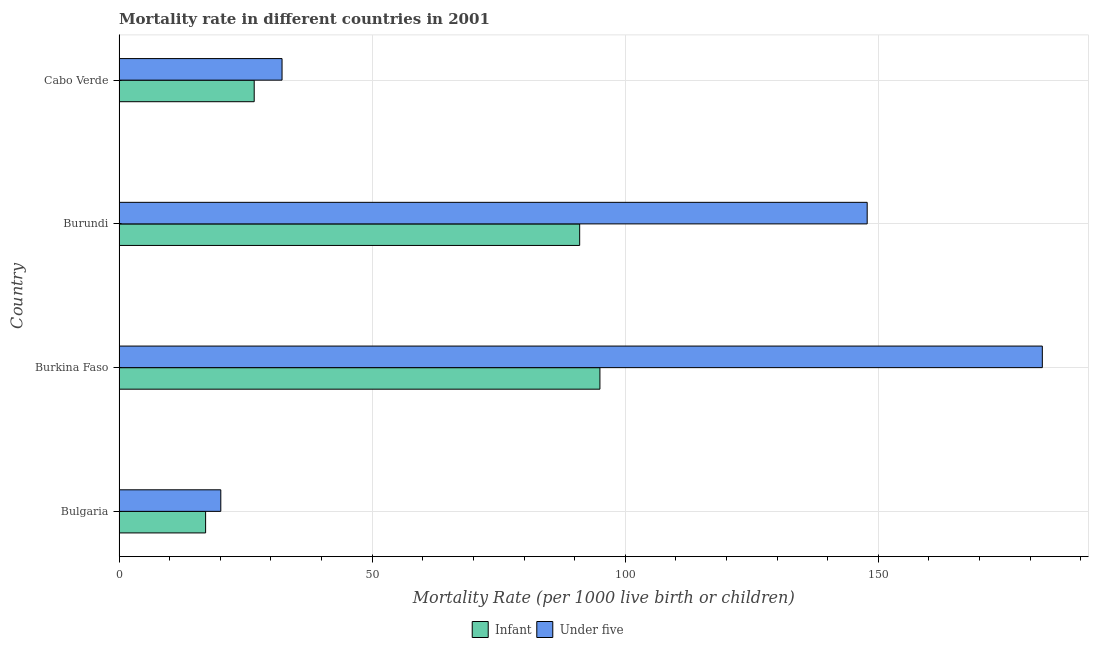How many different coloured bars are there?
Offer a terse response. 2. How many groups of bars are there?
Offer a terse response. 4. Are the number of bars on each tick of the Y-axis equal?
Give a very brief answer. Yes. How many bars are there on the 1st tick from the top?
Ensure brevity in your answer.  2. What is the label of the 4th group of bars from the top?
Keep it short and to the point. Bulgaria. What is the under-5 mortality rate in Bulgaria?
Make the answer very short. 20.1. In which country was the infant mortality rate maximum?
Ensure brevity in your answer.  Burkina Faso. In which country was the under-5 mortality rate minimum?
Your answer should be compact. Bulgaria. What is the total under-5 mortality rate in the graph?
Your answer should be very brief. 382.5. What is the difference between the infant mortality rate in Bulgaria and that in Burundi?
Make the answer very short. -73.9. What is the difference between the infant mortality rate in Burundi and the under-5 mortality rate in Burkina Faso?
Offer a very short reply. -91.4. What is the average under-5 mortality rate per country?
Give a very brief answer. 95.62. What is the ratio of the infant mortality rate in Bulgaria to that in Burundi?
Provide a short and direct response. 0.19. Is the difference between the under-5 mortality rate in Bulgaria and Cabo Verde greater than the difference between the infant mortality rate in Bulgaria and Cabo Verde?
Make the answer very short. No. What is the difference between the highest and the lowest under-5 mortality rate?
Offer a very short reply. 162.3. What does the 1st bar from the top in Burkina Faso represents?
Provide a succinct answer. Under five. What does the 2nd bar from the bottom in Burkina Faso represents?
Your response must be concise. Under five. How many bars are there?
Offer a very short reply. 8. Are all the bars in the graph horizontal?
Your answer should be compact. Yes. How many countries are there in the graph?
Provide a succinct answer. 4. Are the values on the major ticks of X-axis written in scientific E-notation?
Make the answer very short. No. Does the graph contain any zero values?
Give a very brief answer. No. Where does the legend appear in the graph?
Your answer should be very brief. Bottom center. How many legend labels are there?
Give a very brief answer. 2. What is the title of the graph?
Offer a terse response. Mortality rate in different countries in 2001. What is the label or title of the X-axis?
Your response must be concise. Mortality Rate (per 1000 live birth or children). What is the Mortality Rate (per 1000 live birth or children) in Infant in Bulgaria?
Provide a short and direct response. 17.1. What is the Mortality Rate (per 1000 live birth or children) of Under five in Bulgaria?
Offer a terse response. 20.1. What is the Mortality Rate (per 1000 live birth or children) in Infant in Burkina Faso?
Ensure brevity in your answer.  95. What is the Mortality Rate (per 1000 live birth or children) of Under five in Burkina Faso?
Make the answer very short. 182.4. What is the Mortality Rate (per 1000 live birth or children) in Infant in Burundi?
Offer a terse response. 91. What is the Mortality Rate (per 1000 live birth or children) in Under five in Burundi?
Your answer should be compact. 147.8. What is the Mortality Rate (per 1000 live birth or children) in Infant in Cabo Verde?
Keep it short and to the point. 26.7. What is the Mortality Rate (per 1000 live birth or children) in Under five in Cabo Verde?
Provide a short and direct response. 32.2. Across all countries, what is the maximum Mortality Rate (per 1000 live birth or children) in Under five?
Ensure brevity in your answer.  182.4. Across all countries, what is the minimum Mortality Rate (per 1000 live birth or children) of Under five?
Provide a succinct answer. 20.1. What is the total Mortality Rate (per 1000 live birth or children) in Infant in the graph?
Your response must be concise. 229.8. What is the total Mortality Rate (per 1000 live birth or children) in Under five in the graph?
Offer a terse response. 382.5. What is the difference between the Mortality Rate (per 1000 live birth or children) of Infant in Bulgaria and that in Burkina Faso?
Your answer should be very brief. -77.9. What is the difference between the Mortality Rate (per 1000 live birth or children) in Under five in Bulgaria and that in Burkina Faso?
Your answer should be very brief. -162.3. What is the difference between the Mortality Rate (per 1000 live birth or children) of Infant in Bulgaria and that in Burundi?
Your response must be concise. -73.9. What is the difference between the Mortality Rate (per 1000 live birth or children) of Under five in Bulgaria and that in Burundi?
Give a very brief answer. -127.7. What is the difference between the Mortality Rate (per 1000 live birth or children) in Under five in Bulgaria and that in Cabo Verde?
Your answer should be compact. -12.1. What is the difference between the Mortality Rate (per 1000 live birth or children) in Under five in Burkina Faso and that in Burundi?
Provide a succinct answer. 34.6. What is the difference between the Mortality Rate (per 1000 live birth or children) in Infant in Burkina Faso and that in Cabo Verde?
Provide a succinct answer. 68.3. What is the difference between the Mortality Rate (per 1000 live birth or children) of Under five in Burkina Faso and that in Cabo Verde?
Offer a very short reply. 150.2. What is the difference between the Mortality Rate (per 1000 live birth or children) in Infant in Burundi and that in Cabo Verde?
Keep it short and to the point. 64.3. What is the difference between the Mortality Rate (per 1000 live birth or children) of Under five in Burundi and that in Cabo Verde?
Keep it short and to the point. 115.6. What is the difference between the Mortality Rate (per 1000 live birth or children) of Infant in Bulgaria and the Mortality Rate (per 1000 live birth or children) of Under five in Burkina Faso?
Keep it short and to the point. -165.3. What is the difference between the Mortality Rate (per 1000 live birth or children) of Infant in Bulgaria and the Mortality Rate (per 1000 live birth or children) of Under five in Burundi?
Ensure brevity in your answer.  -130.7. What is the difference between the Mortality Rate (per 1000 live birth or children) in Infant in Bulgaria and the Mortality Rate (per 1000 live birth or children) in Under five in Cabo Verde?
Keep it short and to the point. -15.1. What is the difference between the Mortality Rate (per 1000 live birth or children) in Infant in Burkina Faso and the Mortality Rate (per 1000 live birth or children) in Under five in Burundi?
Your response must be concise. -52.8. What is the difference between the Mortality Rate (per 1000 live birth or children) of Infant in Burkina Faso and the Mortality Rate (per 1000 live birth or children) of Under five in Cabo Verde?
Your response must be concise. 62.8. What is the difference between the Mortality Rate (per 1000 live birth or children) in Infant in Burundi and the Mortality Rate (per 1000 live birth or children) in Under five in Cabo Verde?
Your answer should be compact. 58.8. What is the average Mortality Rate (per 1000 live birth or children) in Infant per country?
Give a very brief answer. 57.45. What is the average Mortality Rate (per 1000 live birth or children) of Under five per country?
Give a very brief answer. 95.62. What is the difference between the Mortality Rate (per 1000 live birth or children) of Infant and Mortality Rate (per 1000 live birth or children) of Under five in Burkina Faso?
Give a very brief answer. -87.4. What is the difference between the Mortality Rate (per 1000 live birth or children) in Infant and Mortality Rate (per 1000 live birth or children) in Under five in Burundi?
Provide a succinct answer. -56.8. What is the ratio of the Mortality Rate (per 1000 live birth or children) of Infant in Bulgaria to that in Burkina Faso?
Ensure brevity in your answer.  0.18. What is the ratio of the Mortality Rate (per 1000 live birth or children) in Under five in Bulgaria to that in Burkina Faso?
Ensure brevity in your answer.  0.11. What is the ratio of the Mortality Rate (per 1000 live birth or children) in Infant in Bulgaria to that in Burundi?
Give a very brief answer. 0.19. What is the ratio of the Mortality Rate (per 1000 live birth or children) of Under five in Bulgaria to that in Burundi?
Your answer should be compact. 0.14. What is the ratio of the Mortality Rate (per 1000 live birth or children) in Infant in Bulgaria to that in Cabo Verde?
Offer a terse response. 0.64. What is the ratio of the Mortality Rate (per 1000 live birth or children) in Under five in Bulgaria to that in Cabo Verde?
Your response must be concise. 0.62. What is the ratio of the Mortality Rate (per 1000 live birth or children) of Infant in Burkina Faso to that in Burundi?
Provide a short and direct response. 1.04. What is the ratio of the Mortality Rate (per 1000 live birth or children) of Under five in Burkina Faso to that in Burundi?
Provide a short and direct response. 1.23. What is the ratio of the Mortality Rate (per 1000 live birth or children) in Infant in Burkina Faso to that in Cabo Verde?
Offer a terse response. 3.56. What is the ratio of the Mortality Rate (per 1000 live birth or children) of Under five in Burkina Faso to that in Cabo Verde?
Ensure brevity in your answer.  5.66. What is the ratio of the Mortality Rate (per 1000 live birth or children) of Infant in Burundi to that in Cabo Verde?
Your answer should be compact. 3.41. What is the ratio of the Mortality Rate (per 1000 live birth or children) in Under five in Burundi to that in Cabo Verde?
Give a very brief answer. 4.59. What is the difference between the highest and the second highest Mortality Rate (per 1000 live birth or children) of Under five?
Your answer should be very brief. 34.6. What is the difference between the highest and the lowest Mortality Rate (per 1000 live birth or children) in Infant?
Your response must be concise. 77.9. What is the difference between the highest and the lowest Mortality Rate (per 1000 live birth or children) in Under five?
Offer a very short reply. 162.3. 